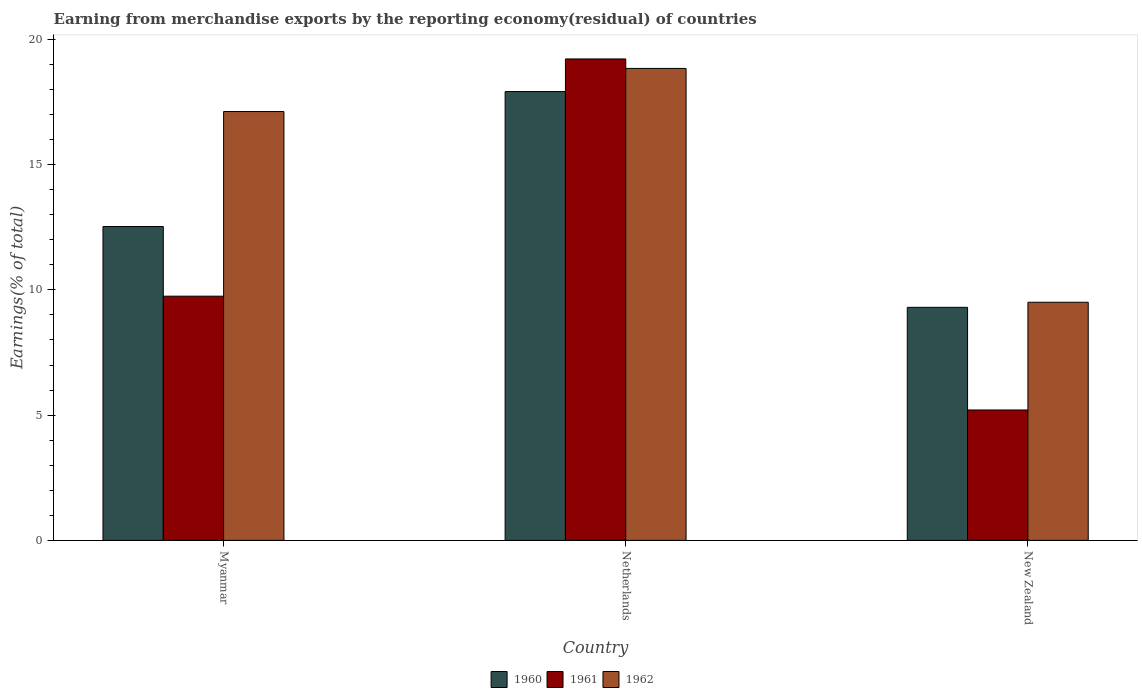How many different coloured bars are there?
Your response must be concise. 3. How many groups of bars are there?
Offer a very short reply. 3. Are the number of bars per tick equal to the number of legend labels?
Provide a succinct answer. Yes. How many bars are there on the 1st tick from the left?
Your answer should be very brief. 3. What is the label of the 2nd group of bars from the left?
Offer a very short reply. Netherlands. What is the percentage of amount earned from merchandise exports in 1961 in Myanmar?
Make the answer very short. 9.75. Across all countries, what is the maximum percentage of amount earned from merchandise exports in 1962?
Offer a very short reply. 18.84. Across all countries, what is the minimum percentage of amount earned from merchandise exports in 1961?
Offer a terse response. 5.21. In which country was the percentage of amount earned from merchandise exports in 1962 maximum?
Offer a terse response. Netherlands. In which country was the percentage of amount earned from merchandise exports in 1961 minimum?
Ensure brevity in your answer.  New Zealand. What is the total percentage of amount earned from merchandise exports in 1961 in the graph?
Provide a short and direct response. 34.17. What is the difference between the percentage of amount earned from merchandise exports in 1960 in Myanmar and that in Netherlands?
Provide a short and direct response. -5.39. What is the difference between the percentage of amount earned from merchandise exports in 1962 in Myanmar and the percentage of amount earned from merchandise exports in 1961 in Netherlands?
Give a very brief answer. -2.1. What is the average percentage of amount earned from merchandise exports in 1962 per country?
Offer a terse response. 15.15. What is the difference between the percentage of amount earned from merchandise exports of/in 1960 and percentage of amount earned from merchandise exports of/in 1961 in Myanmar?
Your answer should be very brief. 2.78. What is the ratio of the percentage of amount earned from merchandise exports in 1962 in Myanmar to that in Netherlands?
Give a very brief answer. 0.91. Is the percentage of amount earned from merchandise exports in 1962 in Myanmar less than that in New Zealand?
Provide a succinct answer. No. What is the difference between the highest and the second highest percentage of amount earned from merchandise exports in 1960?
Your answer should be very brief. 5.39. What is the difference between the highest and the lowest percentage of amount earned from merchandise exports in 1961?
Your answer should be compact. 14.01. In how many countries, is the percentage of amount earned from merchandise exports in 1960 greater than the average percentage of amount earned from merchandise exports in 1960 taken over all countries?
Provide a short and direct response. 1. What does the 2nd bar from the left in New Zealand represents?
Ensure brevity in your answer.  1961. Is it the case that in every country, the sum of the percentage of amount earned from merchandise exports in 1960 and percentage of amount earned from merchandise exports in 1961 is greater than the percentage of amount earned from merchandise exports in 1962?
Provide a succinct answer. Yes. How many bars are there?
Your answer should be very brief. 9. How many countries are there in the graph?
Your answer should be compact. 3. What is the difference between two consecutive major ticks on the Y-axis?
Offer a terse response. 5. Where does the legend appear in the graph?
Provide a succinct answer. Bottom center. What is the title of the graph?
Your answer should be compact. Earning from merchandise exports by the reporting economy(residual) of countries. What is the label or title of the X-axis?
Your response must be concise. Country. What is the label or title of the Y-axis?
Give a very brief answer. Earnings(% of total). What is the Earnings(% of total) in 1960 in Myanmar?
Ensure brevity in your answer.  12.53. What is the Earnings(% of total) in 1961 in Myanmar?
Offer a very short reply. 9.75. What is the Earnings(% of total) of 1962 in Myanmar?
Keep it short and to the point. 17.12. What is the Earnings(% of total) of 1960 in Netherlands?
Make the answer very short. 17.91. What is the Earnings(% of total) in 1961 in Netherlands?
Provide a succinct answer. 19.22. What is the Earnings(% of total) of 1962 in Netherlands?
Provide a succinct answer. 18.84. What is the Earnings(% of total) in 1960 in New Zealand?
Offer a terse response. 9.3. What is the Earnings(% of total) of 1961 in New Zealand?
Ensure brevity in your answer.  5.21. What is the Earnings(% of total) in 1962 in New Zealand?
Provide a short and direct response. 9.51. Across all countries, what is the maximum Earnings(% of total) of 1960?
Offer a very short reply. 17.91. Across all countries, what is the maximum Earnings(% of total) in 1961?
Provide a succinct answer. 19.22. Across all countries, what is the maximum Earnings(% of total) of 1962?
Give a very brief answer. 18.84. Across all countries, what is the minimum Earnings(% of total) in 1960?
Offer a very short reply. 9.3. Across all countries, what is the minimum Earnings(% of total) of 1961?
Offer a very short reply. 5.21. Across all countries, what is the minimum Earnings(% of total) in 1962?
Your answer should be very brief. 9.51. What is the total Earnings(% of total) of 1960 in the graph?
Keep it short and to the point. 39.75. What is the total Earnings(% of total) in 1961 in the graph?
Keep it short and to the point. 34.17. What is the total Earnings(% of total) of 1962 in the graph?
Offer a terse response. 45.46. What is the difference between the Earnings(% of total) in 1960 in Myanmar and that in Netherlands?
Your answer should be very brief. -5.39. What is the difference between the Earnings(% of total) of 1961 in Myanmar and that in Netherlands?
Provide a succinct answer. -9.47. What is the difference between the Earnings(% of total) of 1962 in Myanmar and that in Netherlands?
Provide a short and direct response. -1.72. What is the difference between the Earnings(% of total) of 1960 in Myanmar and that in New Zealand?
Offer a terse response. 3.23. What is the difference between the Earnings(% of total) of 1961 in Myanmar and that in New Zealand?
Provide a succinct answer. 4.54. What is the difference between the Earnings(% of total) in 1962 in Myanmar and that in New Zealand?
Your answer should be very brief. 7.61. What is the difference between the Earnings(% of total) of 1960 in Netherlands and that in New Zealand?
Offer a terse response. 8.61. What is the difference between the Earnings(% of total) in 1961 in Netherlands and that in New Zealand?
Give a very brief answer. 14.01. What is the difference between the Earnings(% of total) of 1962 in Netherlands and that in New Zealand?
Ensure brevity in your answer.  9.33. What is the difference between the Earnings(% of total) in 1960 in Myanmar and the Earnings(% of total) in 1961 in Netherlands?
Offer a terse response. -6.69. What is the difference between the Earnings(% of total) of 1960 in Myanmar and the Earnings(% of total) of 1962 in Netherlands?
Offer a very short reply. -6.31. What is the difference between the Earnings(% of total) of 1961 in Myanmar and the Earnings(% of total) of 1962 in Netherlands?
Your response must be concise. -9.09. What is the difference between the Earnings(% of total) of 1960 in Myanmar and the Earnings(% of total) of 1961 in New Zealand?
Offer a very short reply. 7.32. What is the difference between the Earnings(% of total) in 1960 in Myanmar and the Earnings(% of total) in 1962 in New Zealand?
Make the answer very short. 3.02. What is the difference between the Earnings(% of total) of 1961 in Myanmar and the Earnings(% of total) of 1962 in New Zealand?
Make the answer very short. 0.24. What is the difference between the Earnings(% of total) of 1960 in Netherlands and the Earnings(% of total) of 1961 in New Zealand?
Ensure brevity in your answer.  12.71. What is the difference between the Earnings(% of total) of 1960 in Netherlands and the Earnings(% of total) of 1962 in New Zealand?
Ensure brevity in your answer.  8.41. What is the difference between the Earnings(% of total) in 1961 in Netherlands and the Earnings(% of total) in 1962 in New Zealand?
Provide a succinct answer. 9.71. What is the average Earnings(% of total) in 1960 per country?
Make the answer very short. 13.25. What is the average Earnings(% of total) of 1961 per country?
Offer a very short reply. 11.39. What is the average Earnings(% of total) in 1962 per country?
Keep it short and to the point. 15.15. What is the difference between the Earnings(% of total) of 1960 and Earnings(% of total) of 1961 in Myanmar?
Provide a short and direct response. 2.78. What is the difference between the Earnings(% of total) in 1960 and Earnings(% of total) in 1962 in Myanmar?
Offer a very short reply. -4.59. What is the difference between the Earnings(% of total) of 1961 and Earnings(% of total) of 1962 in Myanmar?
Your response must be concise. -7.37. What is the difference between the Earnings(% of total) of 1960 and Earnings(% of total) of 1961 in Netherlands?
Offer a very short reply. -1.3. What is the difference between the Earnings(% of total) of 1960 and Earnings(% of total) of 1962 in Netherlands?
Make the answer very short. -0.92. What is the difference between the Earnings(% of total) in 1961 and Earnings(% of total) in 1962 in Netherlands?
Your answer should be compact. 0.38. What is the difference between the Earnings(% of total) in 1960 and Earnings(% of total) in 1961 in New Zealand?
Keep it short and to the point. 4.1. What is the difference between the Earnings(% of total) of 1960 and Earnings(% of total) of 1962 in New Zealand?
Your response must be concise. -0.2. What is the difference between the Earnings(% of total) in 1961 and Earnings(% of total) in 1962 in New Zealand?
Your answer should be very brief. -4.3. What is the ratio of the Earnings(% of total) of 1960 in Myanmar to that in Netherlands?
Your answer should be compact. 0.7. What is the ratio of the Earnings(% of total) in 1961 in Myanmar to that in Netherlands?
Make the answer very short. 0.51. What is the ratio of the Earnings(% of total) in 1962 in Myanmar to that in Netherlands?
Keep it short and to the point. 0.91. What is the ratio of the Earnings(% of total) of 1960 in Myanmar to that in New Zealand?
Your answer should be very brief. 1.35. What is the ratio of the Earnings(% of total) of 1961 in Myanmar to that in New Zealand?
Give a very brief answer. 1.87. What is the ratio of the Earnings(% of total) in 1962 in Myanmar to that in New Zealand?
Give a very brief answer. 1.8. What is the ratio of the Earnings(% of total) of 1960 in Netherlands to that in New Zealand?
Provide a short and direct response. 1.93. What is the ratio of the Earnings(% of total) of 1961 in Netherlands to that in New Zealand?
Offer a very short reply. 3.69. What is the ratio of the Earnings(% of total) in 1962 in Netherlands to that in New Zealand?
Your answer should be very brief. 1.98. What is the difference between the highest and the second highest Earnings(% of total) in 1960?
Offer a very short reply. 5.39. What is the difference between the highest and the second highest Earnings(% of total) of 1961?
Keep it short and to the point. 9.47. What is the difference between the highest and the second highest Earnings(% of total) in 1962?
Your response must be concise. 1.72. What is the difference between the highest and the lowest Earnings(% of total) of 1960?
Give a very brief answer. 8.61. What is the difference between the highest and the lowest Earnings(% of total) in 1961?
Make the answer very short. 14.01. What is the difference between the highest and the lowest Earnings(% of total) of 1962?
Make the answer very short. 9.33. 